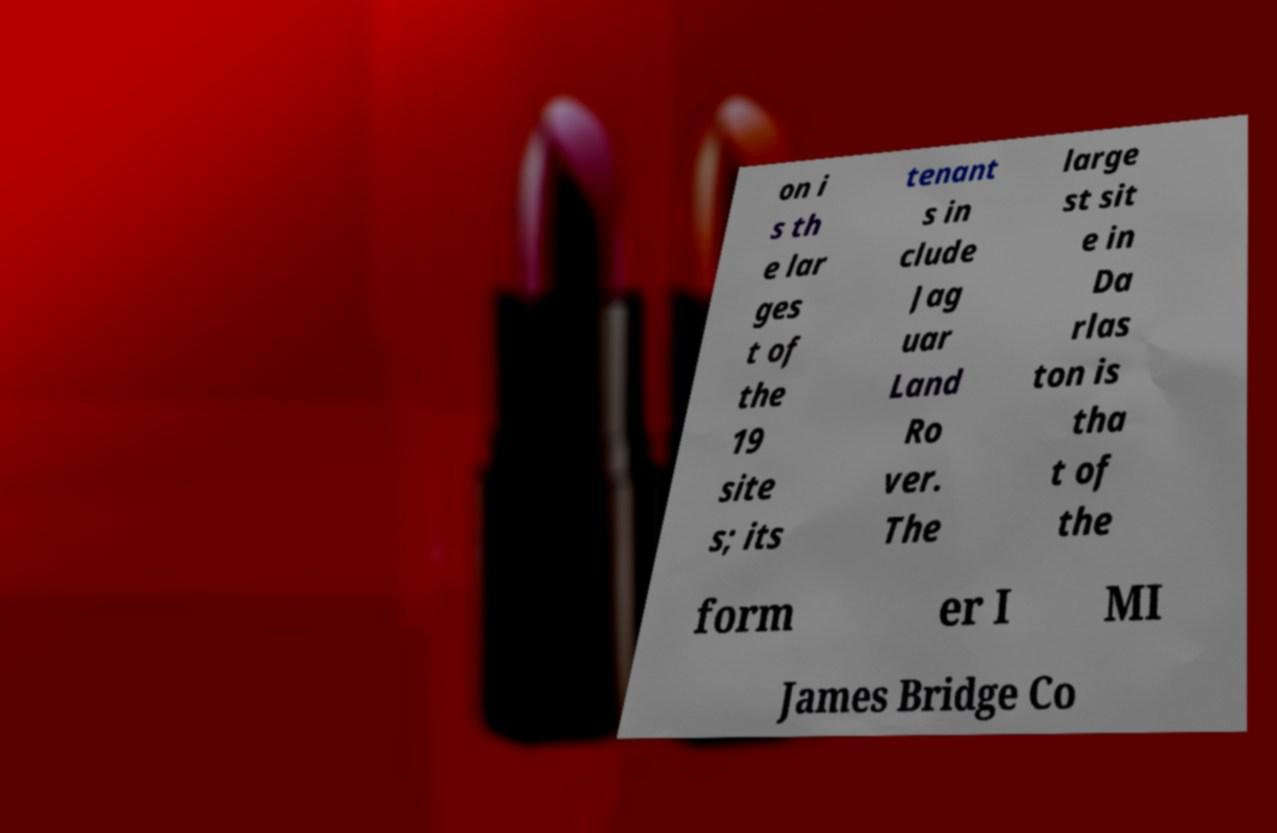Please read and relay the text visible in this image. What does it say? on i s th e lar ges t of the 19 site s; its tenant s in clude Jag uar Land Ro ver. The large st sit e in Da rlas ton is tha t of the form er I MI James Bridge Co 